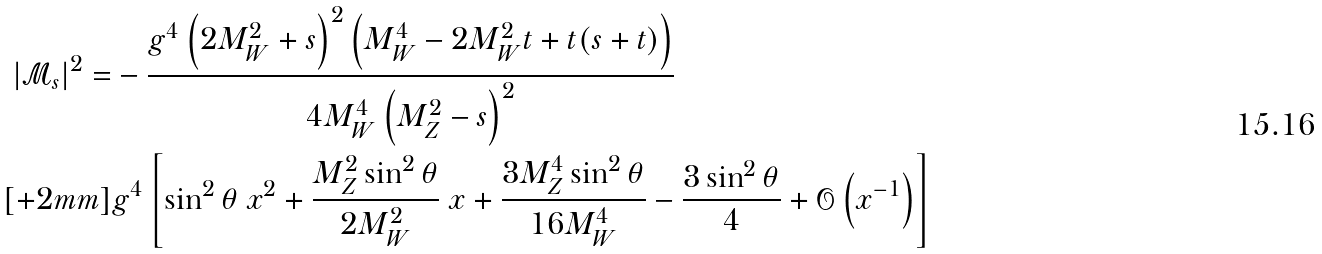<formula> <loc_0><loc_0><loc_500><loc_500>| \mathcal { M } _ { s } | ^ { 2 } = & - \frac { g ^ { 4 } \left ( 2 M _ { W } ^ { 2 } + s \right ) ^ { 2 } \left ( M _ { W } ^ { 4 } - 2 M _ { W } ^ { 2 } t + t ( s + t ) \right ) } { 4 M _ { W } ^ { 4 } \left ( M _ { Z } ^ { 2 } - s \right ) ^ { 2 } } \\ [ + 2 m m ] & g ^ { 4 } \left [ \sin ^ { 2 } \theta \ x ^ { 2 } + \frac { M _ { Z } ^ { 2 } \sin ^ { 2 } \theta } { 2 M _ { W } ^ { 2 } } \ x + \frac { 3 M _ { Z } ^ { 4 } \sin ^ { 2 } \theta } { 1 6 M _ { W } ^ { 4 } } - \frac { 3 \sin ^ { 2 } \theta } { 4 } + \mathcal { O } \left ( x ^ { - 1 } \right ) \right ]</formula> 